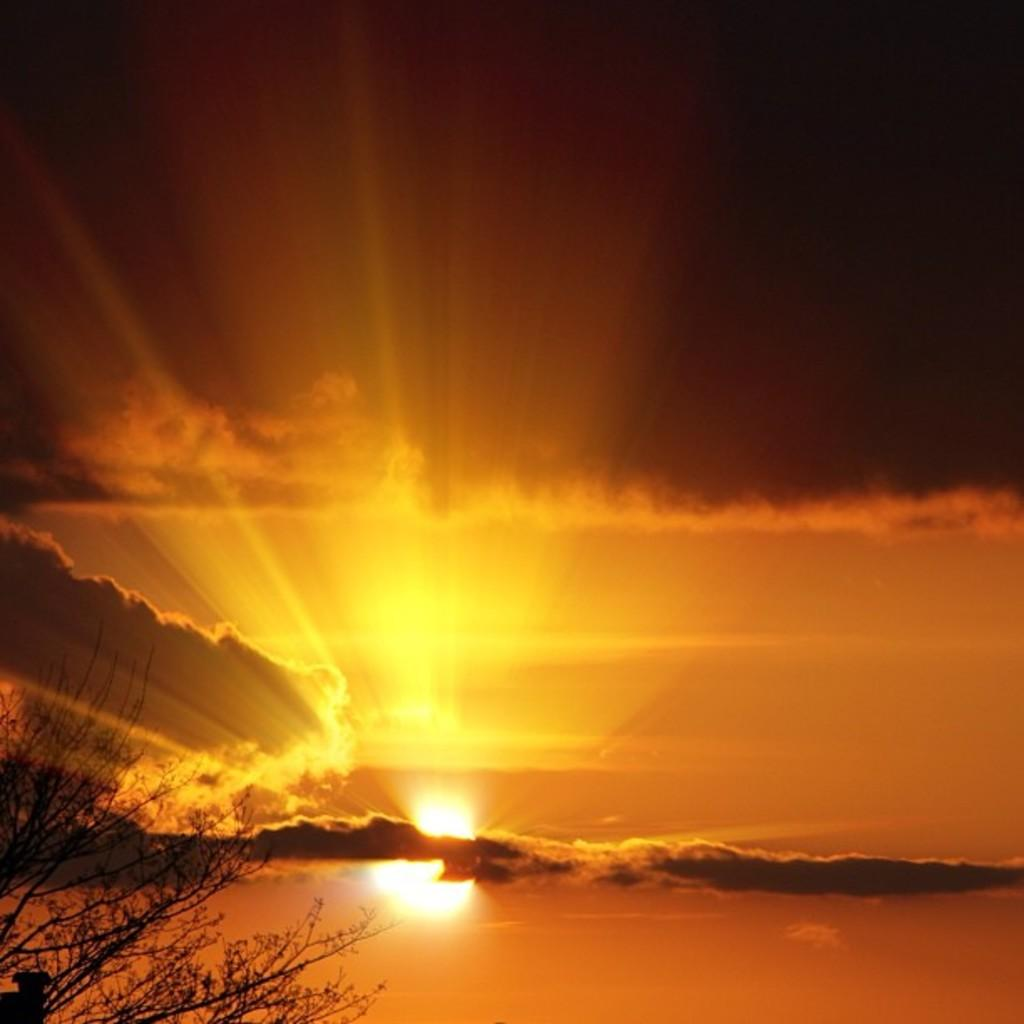What type of vegetation is present in the image? There is a tree in the image. What part of the natural environment is visible in the image? The sky is visible in the image. Can the sun be seen in the image? Yes, the sun is observable in the sky. Where is the giraffe located in the image? There is no giraffe present in the image. What type of ring can be seen on the tree in the image? There is no ring present on the tree in the image. 